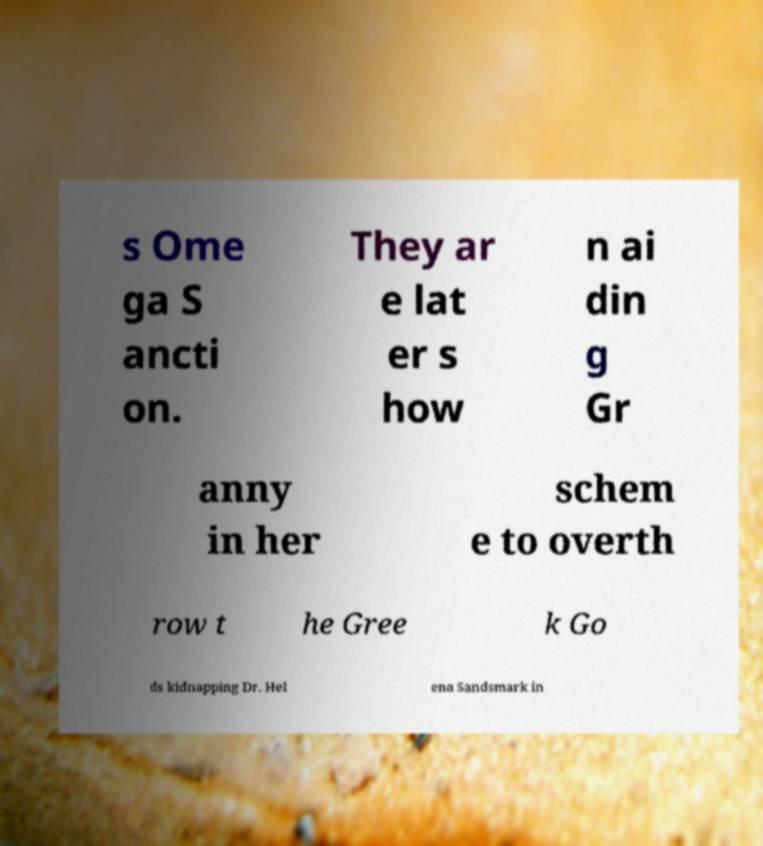What messages or text are displayed in this image? I need them in a readable, typed format. s Ome ga S ancti on. They ar e lat er s how n ai din g Gr anny in her schem e to overth row t he Gree k Go ds kidnapping Dr. Hel ena Sandsmark in 